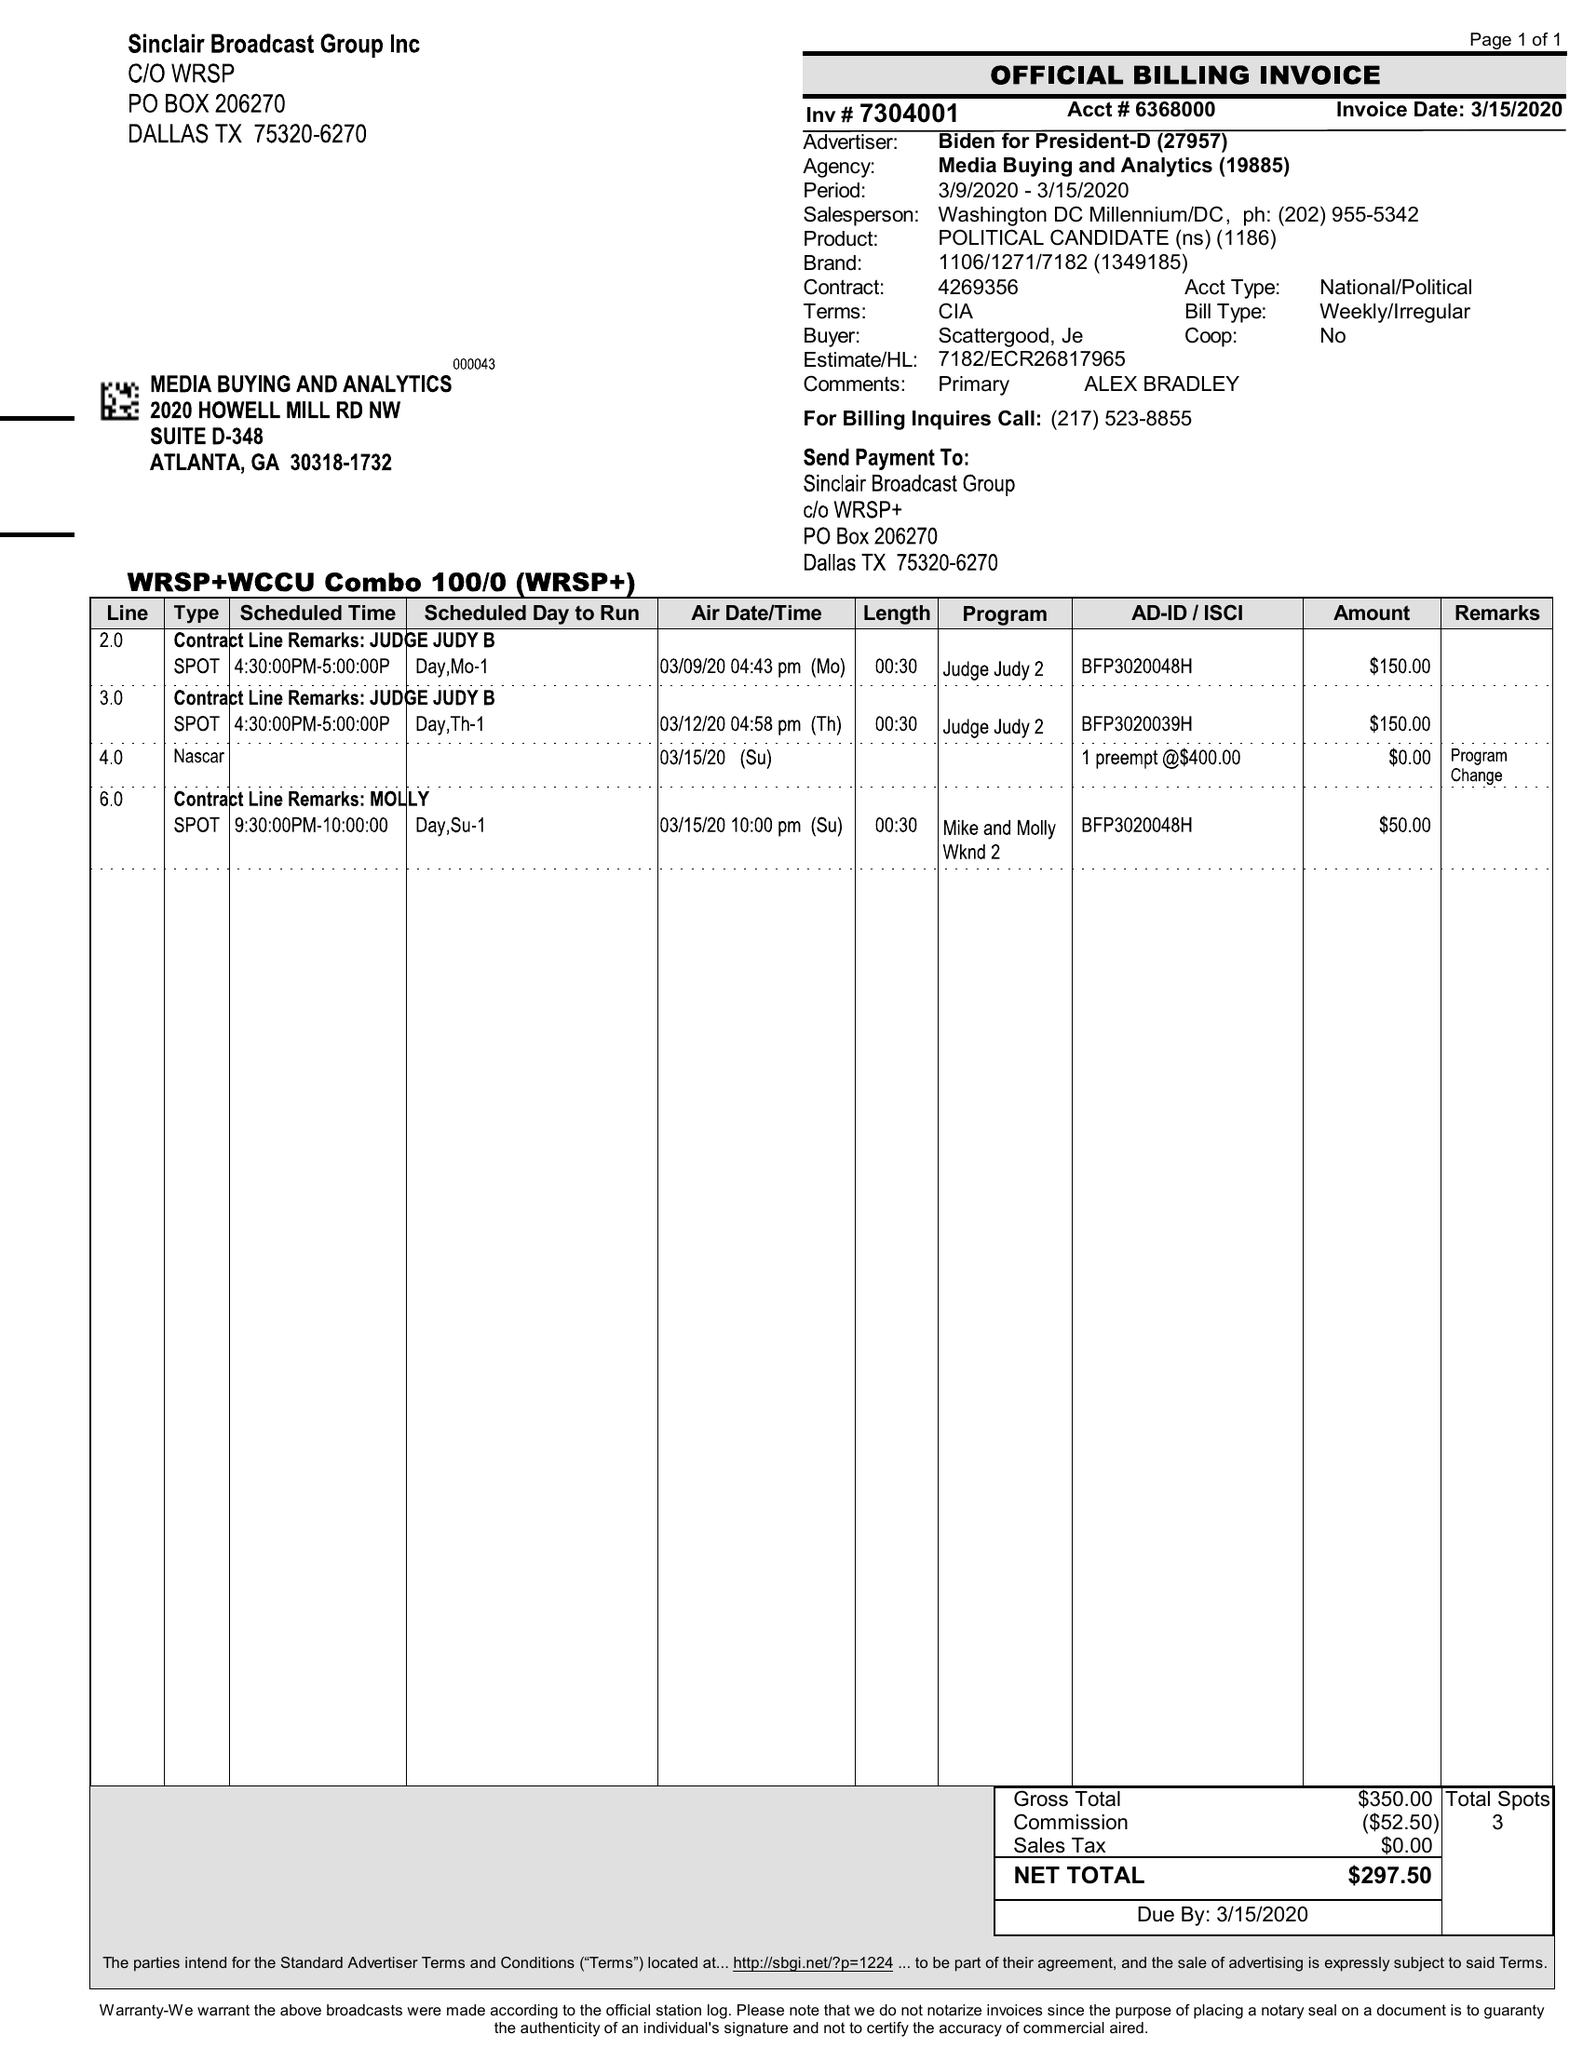What is the value for the flight_from?
Answer the question using a single word or phrase. 03/09/20 